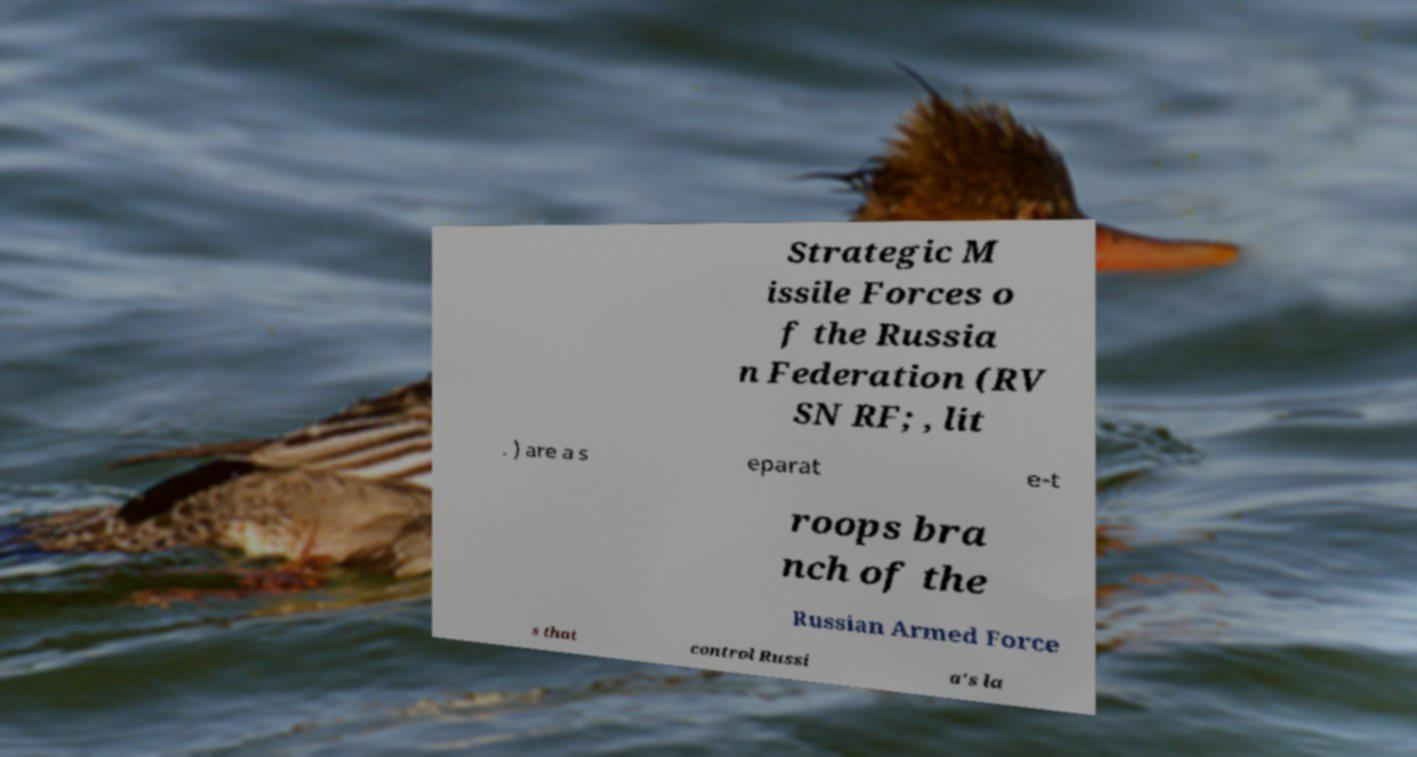Please read and relay the text visible in this image. What does it say? Strategic M issile Forces o f the Russia n Federation (RV SN RF; , lit . ) are a s eparat e-t roops bra nch of the Russian Armed Force s that control Russi a's la 